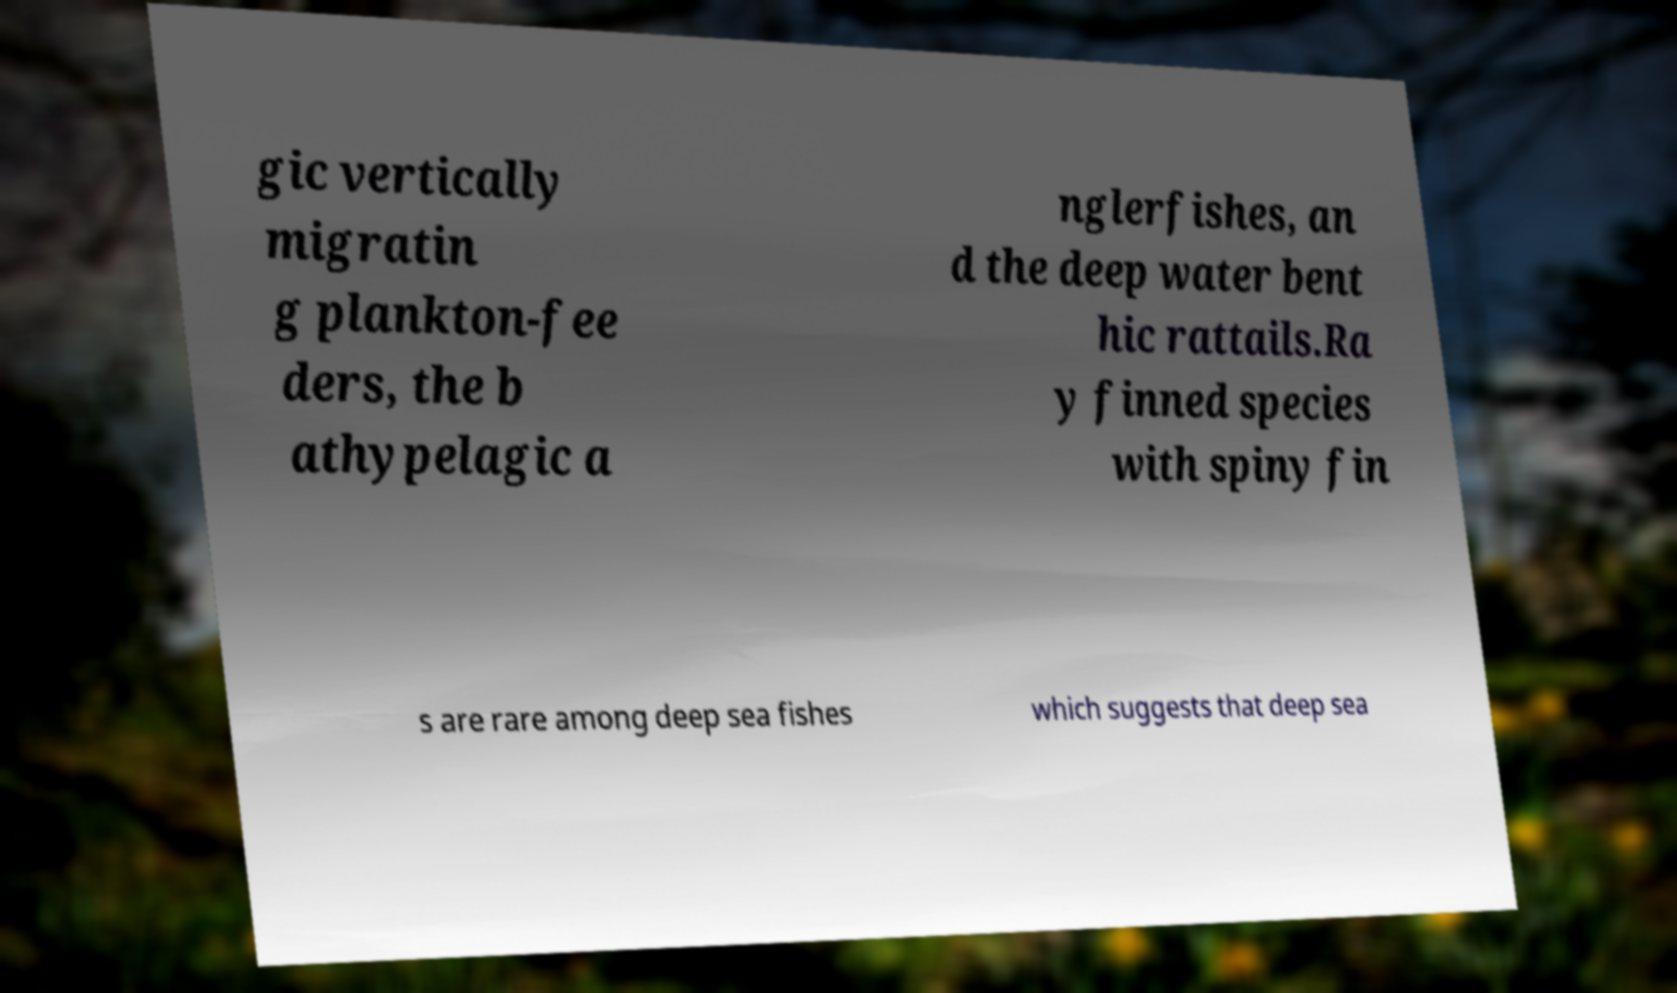Can you accurately transcribe the text from the provided image for me? gic vertically migratin g plankton-fee ders, the b athypelagic a nglerfishes, an d the deep water bent hic rattails.Ra y finned species with spiny fin s are rare among deep sea fishes which suggests that deep sea 